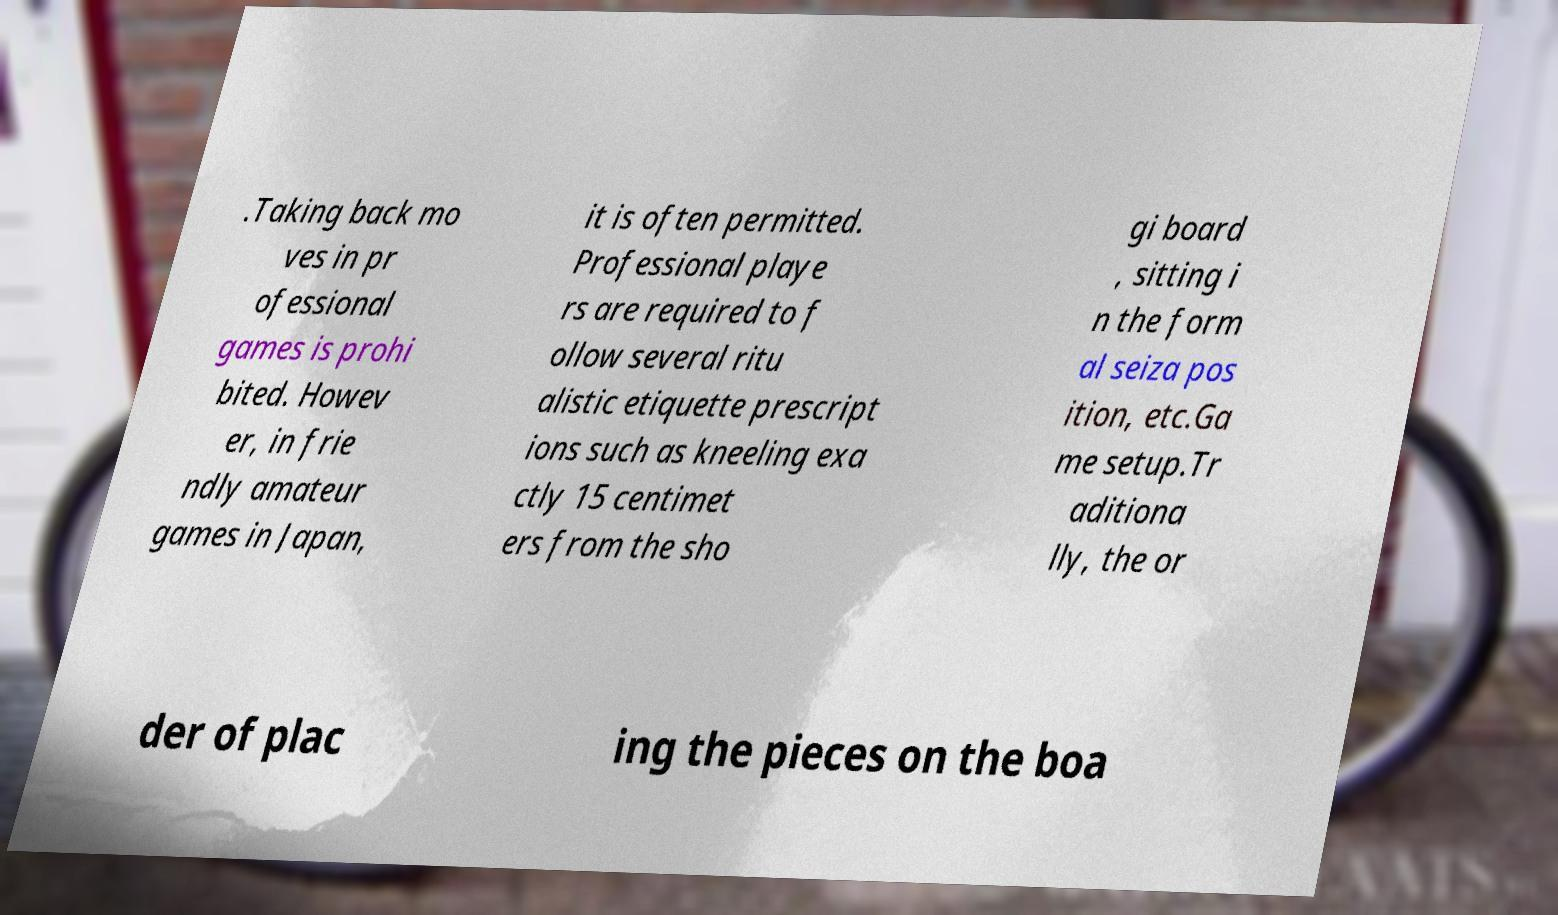Could you extract and type out the text from this image? .Taking back mo ves in pr ofessional games is prohi bited. Howev er, in frie ndly amateur games in Japan, it is often permitted. Professional playe rs are required to f ollow several ritu alistic etiquette prescript ions such as kneeling exa ctly 15 centimet ers from the sho gi board , sitting i n the form al seiza pos ition, etc.Ga me setup.Tr aditiona lly, the or der of plac ing the pieces on the boa 